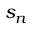<formula> <loc_0><loc_0><loc_500><loc_500>s _ { n }</formula> 